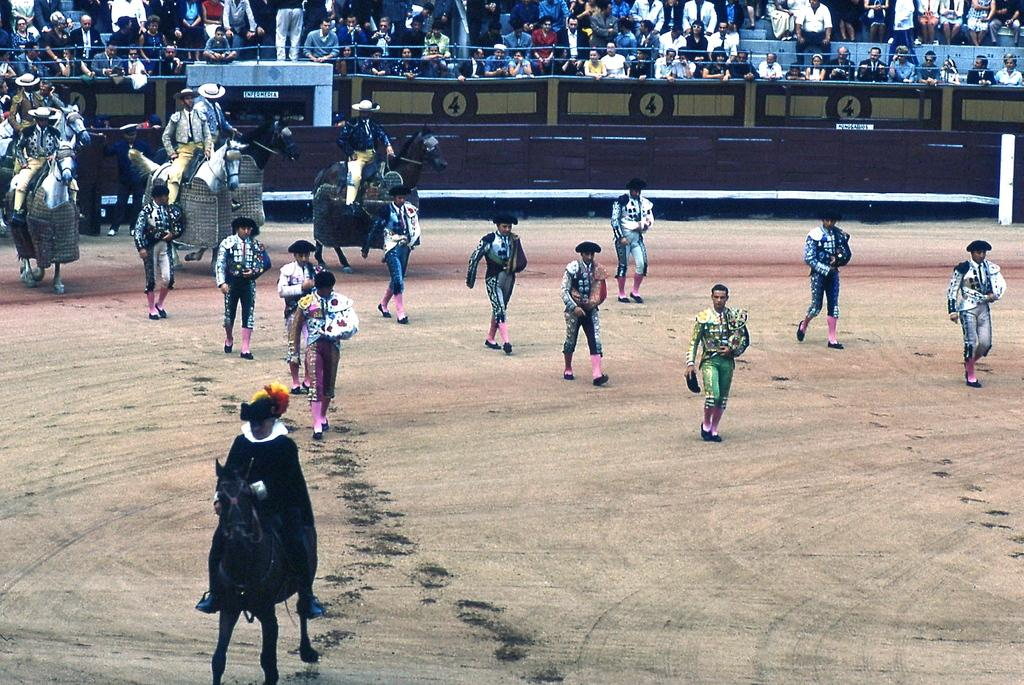What is happening in the image? There is a group of people standing in the image. Where are the people standing? The people are standing on the ground. What else can be seen in the image besides the group of people? There is a horse in the image. What can be seen in the background of the image? There are chairs and another group of people in the background of the image. What type of muscle is the horse flexing in the image? There is no indication of the horse flexing any muscles in the image. 